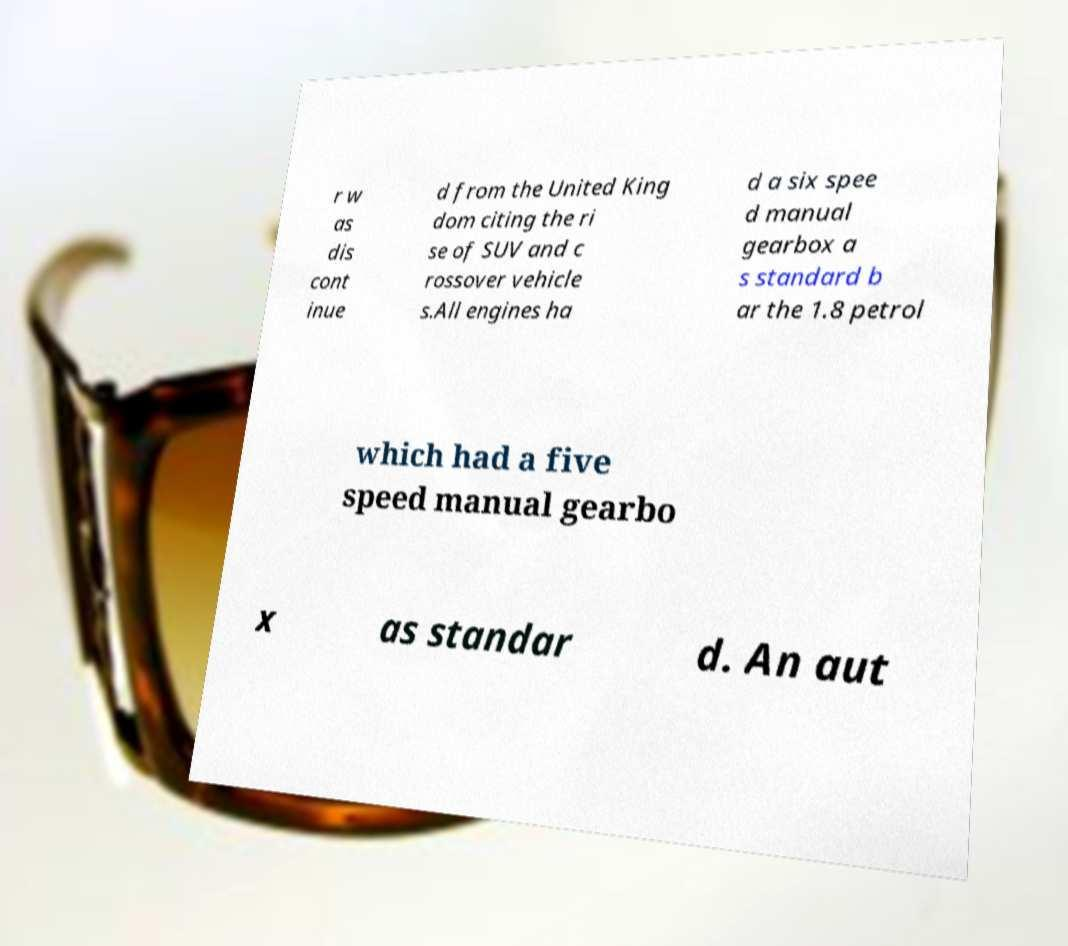Could you assist in decoding the text presented in this image and type it out clearly? r w as dis cont inue d from the United King dom citing the ri se of SUV and c rossover vehicle s.All engines ha d a six spee d manual gearbox a s standard b ar the 1.8 petrol which had a five speed manual gearbo x as standar d. An aut 